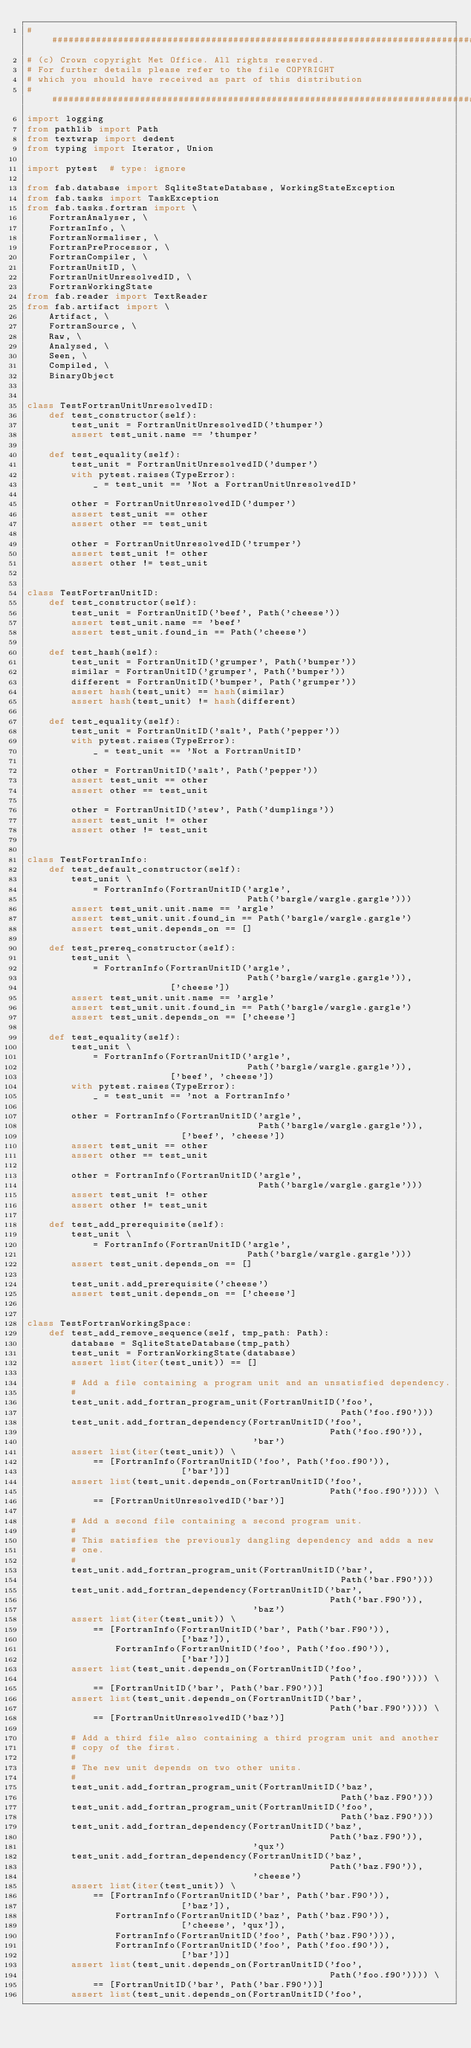<code> <loc_0><loc_0><loc_500><loc_500><_Python_>##############################################################################
# (c) Crown copyright Met Office. All rights reserved.
# For further details please refer to the file COPYRIGHT
# which you should have received as part of this distribution
##############################################################################
import logging
from pathlib import Path
from textwrap import dedent
from typing import Iterator, Union

import pytest  # type: ignore

from fab.database import SqliteStateDatabase, WorkingStateException
from fab.tasks import TaskException
from fab.tasks.fortran import \
    FortranAnalyser, \
    FortranInfo, \
    FortranNormaliser, \
    FortranPreProcessor, \
    FortranCompiler, \
    FortranUnitID, \
    FortranUnitUnresolvedID, \
    FortranWorkingState
from fab.reader import TextReader
from fab.artifact import \
    Artifact, \
    FortranSource, \
    Raw, \
    Analysed, \
    Seen, \
    Compiled, \
    BinaryObject


class TestFortranUnitUnresolvedID:
    def test_constructor(self):
        test_unit = FortranUnitUnresolvedID('thumper')
        assert test_unit.name == 'thumper'

    def test_equality(self):
        test_unit = FortranUnitUnresolvedID('dumper')
        with pytest.raises(TypeError):
            _ = test_unit == 'Not a FortranUnitUnresolvedID'

        other = FortranUnitUnresolvedID('dumper')
        assert test_unit == other
        assert other == test_unit

        other = FortranUnitUnresolvedID('trumper')
        assert test_unit != other
        assert other != test_unit


class TestFortranUnitID:
    def test_constructor(self):
        test_unit = FortranUnitID('beef', Path('cheese'))
        assert test_unit.name == 'beef'
        assert test_unit.found_in == Path('cheese')

    def test_hash(self):
        test_unit = FortranUnitID('grumper', Path('bumper'))
        similar = FortranUnitID('grumper', Path('bumper'))
        different = FortranUnitID('bumper', Path('grumper'))
        assert hash(test_unit) == hash(similar)
        assert hash(test_unit) != hash(different)

    def test_equality(self):
        test_unit = FortranUnitID('salt', Path('pepper'))
        with pytest.raises(TypeError):
            _ = test_unit == 'Not a FortranUnitID'

        other = FortranUnitID('salt', Path('pepper'))
        assert test_unit == other
        assert other == test_unit

        other = FortranUnitID('stew', Path('dumplings'))
        assert test_unit != other
        assert other != test_unit


class TestFortranInfo:
    def test_default_constructor(self):
        test_unit \
            = FortranInfo(FortranUnitID('argle',
                                        Path('bargle/wargle.gargle')))
        assert test_unit.unit.name == 'argle'
        assert test_unit.unit.found_in == Path('bargle/wargle.gargle')
        assert test_unit.depends_on == []

    def test_prereq_constructor(self):
        test_unit \
            = FortranInfo(FortranUnitID('argle',
                                        Path('bargle/wargle.gargle')),
                          ['cheese'])
        assert test_unit.unit.name == 'argle'
        assert test_unit.unit.found_in == Path('bargle/wargle.gargle')
        assert test_unit.depends_on == ['cheese']

    def test_equality(self):
        test_unit \
            = FortranInfo(FortranUnitID('argle',
                                        Path('bargle/wargle.gargle')),
                          ['beef', 'cheese'])
        with pytest.raises(TypeError):
            _ = test_unit == 'not a FortranInfo'

        other = FortranInfo(FortranUnitID('argle',
                                          Path('bargle/wargle.gargle')),
                            ['beef', 'cheese'])
        assert test_unit == other
        assert other == test_unit

        other = FortranInfo(FortranUnitID('argle',
                                          Path('bargle/wargle.gargle')))
        assert test_unit != other
        assert other != test_unit

    def test_add_prerequisite(self):
        test_unit \
            = FortranInfo(FortranUnitID('argle',
                                        Path('bargle/wargle.gargle')))
        assert test_unit.depends_on == []

        test_unit.add_prerequisite('cheese')
        assert test_unit.depends_on == ['cheese']


class TestFortranWorkingSpace:
    def test_add_remove_sequence(self, tmp_path: Path):
        database = SqliteStateDatabase(tmp_path)
        test_unit = FortranWorkingState(database)
        assert list(iter(test_unit)) == []

        # Add a file containing a program unit and an unsatisfied dependency.
        #
        test_unit.add_fortran_program_unit(FortranUnitID('foo',
                                                         Path('foo.f90')))
        test_unit.add_fortran_dependency(FortranUnitID('foo',
                                                       Path('foo.f90')),
                                         'bar')
        assert list(iter(test_unit)) \
            == [FortranInfo(FortranUnitID('foo', Path('foo.f90')),
                            ['bar'])]
        assert list(test_unit.depends_on(FortranUnitID('foo',
                                                       Path('foo.f90')))) \
            == [FortranUnitUnresolvedID('bar')]

        # Add a second file containing a second program unit.
        #
        # This satisfies the previously dangling dependency and adds a new
        # one.
        #
        test_unit.add_fortran_program_unit(FortranUnitID('bar',
                                                         Path('bar.F90')))
        test_unit.add_fortran_dependency(FortranUnitID('bar',
                                                       Path('bar.F90')),
                                         'baz')
        assert list(iter(test_unit)) \
            == [FortranInfo(FortranUnitID('bar', Path('bar.F90')),
                            ['baz']),
                FortranInfo(FortranUnitID('foo', Path('foo.f90')),
                            ['bar'])]
        assert list(test_unit.depends_on(FortranUnitID('foo',
                                                       Path('foo.f90')))) \
            == [FortranUnitID('bar', Path('bar.F90'))]
        assert list(test_unit.depends_on(FortranUnitID('bar',
                                                       Path('bar.F90')))) \
            == [FortranUnitUnresolvedID('baz')]

        # Add a third file also containing a third program unit and another
        # copy of the first.
        #
        # The new unit depends on two other units.
        #
        test_unit.add_fortran_program_unit(FortranUnitID('baz',
                                                         Path('baz.F90')))
        test_unit.add_fortran_program_unit(FortranUnitID('foo',
                                                         Path('baz.F90')))
        test_unit.add_fortran_dependency(FortranUnitID('baz',
                                                       Path('baz.F90')),
                                         'qux')
        test_unit.add_fortran_dependency(FortranUnitID('baz',
                                                       Path('baz.F90')),
                                         'cheese')
        assert list(iter(test_unit)) \
            == [FortranInfo(FortranUnitID('bar', Path('bar.F90')),
                            ['baz']),
                FortranInfo(FortranUnitID('baz', Path('baz.F90')),
                            ['cheese', 'qux']),
                FortranInfo(FortranUnitID('foo', Path('baz.F90'))),
                FortranInfo(FortranUnitID('foo', Path('foo.f90')),
                            ['bar'])]
        assert list(test_unit.depends_on(FortranUnitID('foo',
                                                       Path('foo.f90')))) \
            == [FortranUnitID('bar', Path('bar.F90'))]
        assert list(test_unit.depends_on(FortranUnitID('foo',</code> 